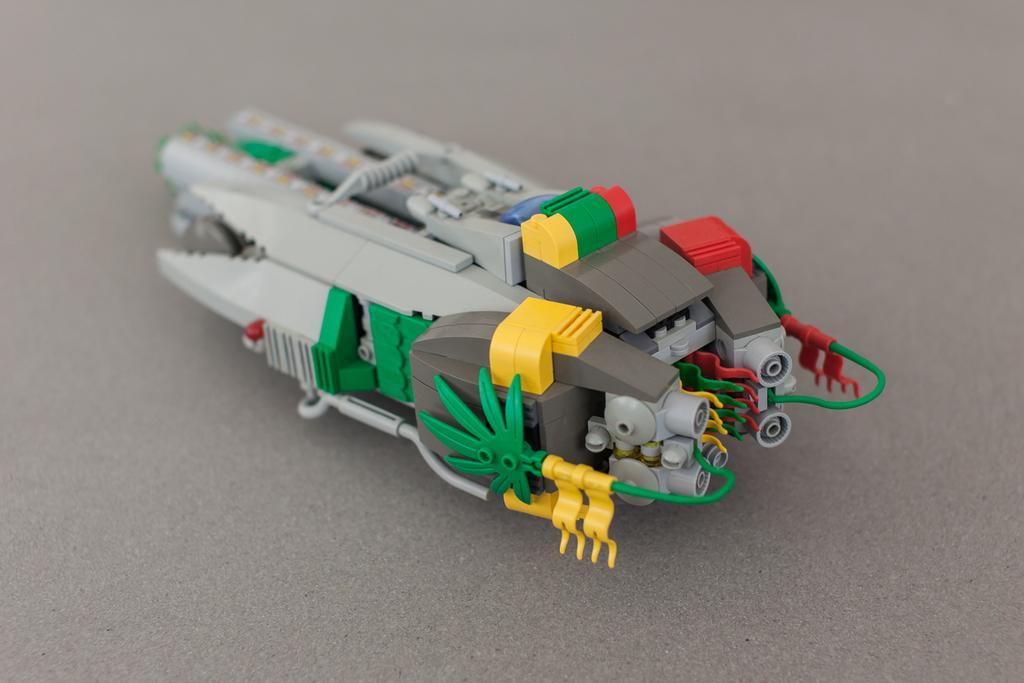How would you summarize this image in a sentence or two? In this image we can see a toy on a gray surface. 